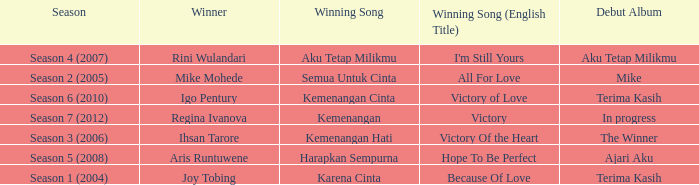Which album debuted in season 2 (2005)? Mike. 